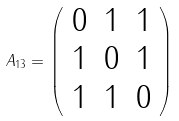Convert formula to latex. <formula><loc_0><loc_0><loc_500><loc_500>A _ { 1 3 } = \left ( \begin{array} { c c c } 0 & 1 & 1 \\ 1 & 0 & 1 \\ 1 & 1 & 0 \\ \end{array} \right )</formula> 